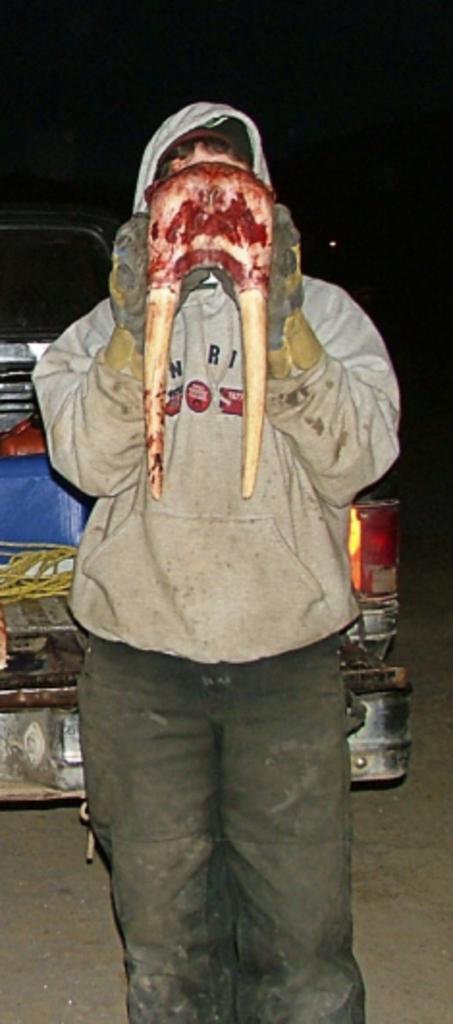Could you give a brief overview of what you see in this image? In this picture we can see a man, and he is holding something in his hand, behind to him we can see a vehicle. 